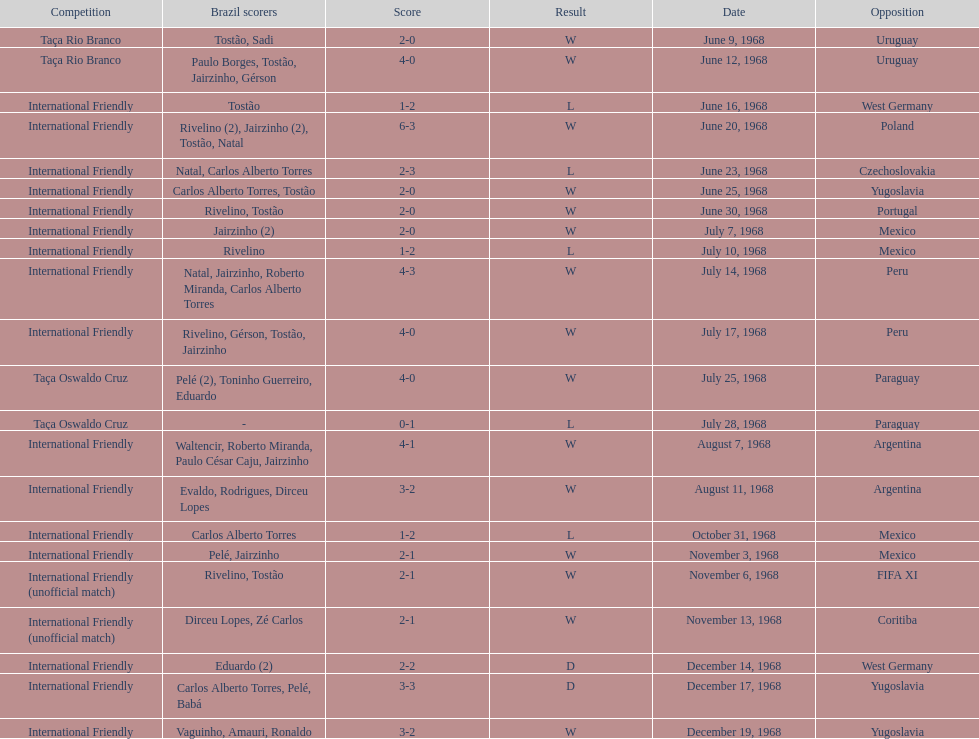What is the top score ever scored by the brazil national team? 6. 